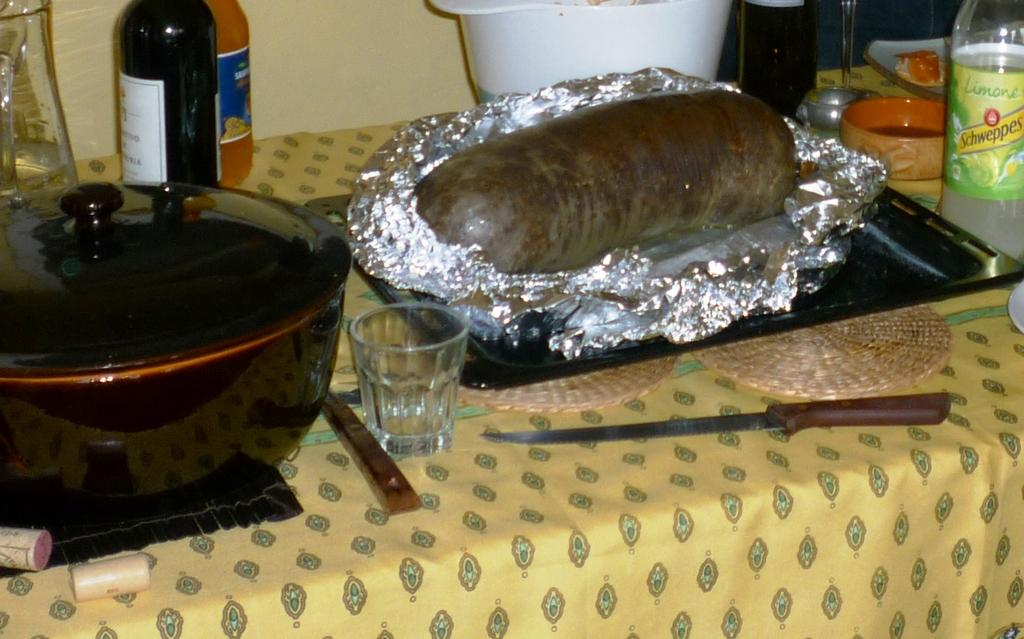<image>
Render a clear and concise summary of the photo. A large sausage wrapped with foil in a baking pan next to a bottle of Schweppes Limone juice. 